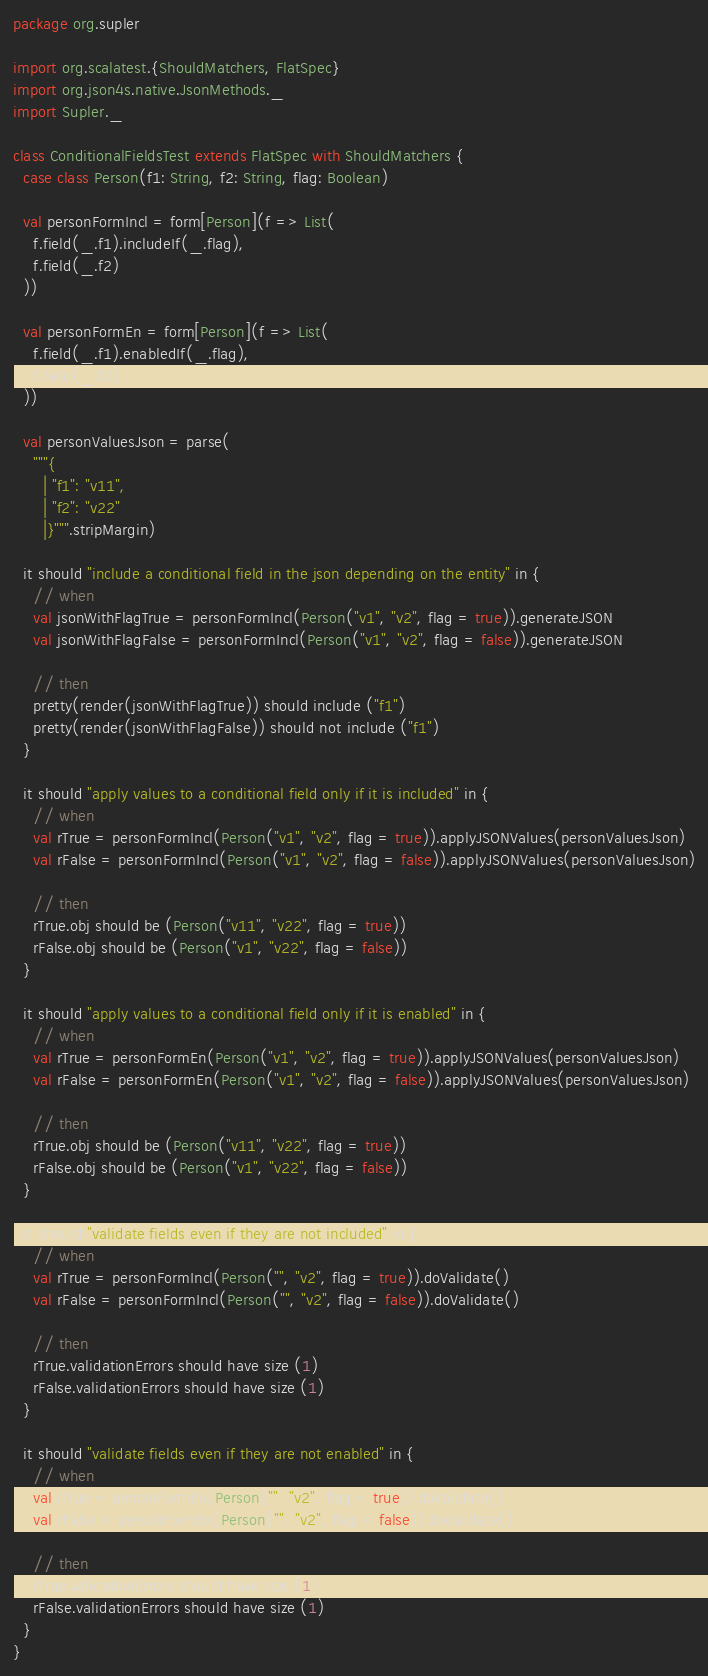<code> <loc_0><loc_0><loc_500><loc_500><_Scala_>package org.supler

import org.scalatest.{ShouldMatchers, FlatSpec}
import org.json4s.native.JsonMethods._
import Supler._

class ConditionalFieldsTest extends FlatSpec with ShouldMatchers {
  case class Person(f1: String, f2: String, flag: Boolean)

  val personFormIncl = form[Person](f => List(
    f.field(_.f1).includeIf(_.flag),
    f.field(_.f2)
  ))

  val personFormEn = form[Person](f => List(
    f.field(_.f1).enabledIf(_.flag),
    f.field(_.f2)
  ))

  val personValuesJson = parse(
    """{
      | "f1": "v11",
      | "f2": "v22"
      |}""".stripMargin)

  it should "include a conditional field in the json depending on the entity" in {
    // when
    val jsonWithFlagTrue = personFormIncl(Person("v1", "v2", flag = true)).generateJSON
    val jsonWithFlagFalse = personFormIncl(Person("v1", "v2", flag = false)).generateJSON

    // then
    pretty(render(jsonWithFlagTrue)) should include ("f1")
    pretty(render(jsonWithFlagFalse)) should not include ("f1")
  }

  it should "apply values to a conditional field only if it is included" in {
    // when
    val rTrue = personFormIncl(Person("v1", "v2", flag = true)).applyJSONValues(personValuesJson)
    val rFalse = personFormIncl(Person("v1", "v2", flag = false)).applyJSONValues(personValuesJson)

    // then
    rTrue.obj should be (Person("v11", "v22", flag = true))
    rFalse.obj should be (Person("v1", "v22", flag = false))
  }

  it should "apply values to a conditional field only if it is enabled" in {
    // when
    val rTrue = personFormEn(Person("v1", "v2", flag = true)).applyJSONValues(personValuesJson)
    val rFalse = personFormEn(Person("v1", "v2", flag = false)).applyJSONValues(personValuesJson)

    // then
    rTrue.obj should be (Person("v11", "v22", flag = true))
    rFalse.obj should be (Person("v1", "v22", flag = false))
  }

  it should "validate fields even if they are not included" in {
    // when
    val rTrue = personFormIncl(Person("", "v2", flag = true)).doValidate()
    val rFalse = personFormIncl(Person("", "v2", flag = false)).doValidate()

    // then
    rTrue.validationErrors should have size (1)
    rFalse.validationErrors should have size (1)
  }

  it should "validate fields even if they are not enabled" in {
    // when
    val rTrue = personFormEn(Person("", "v2", flag = true)).doValidate()
    val rFalse = personFormEn(Person("", "v2", flag = false)).doValidate()

    // then
    rTrue.validationErrors should have size (1)
    rFalse.validationErrors should have size (1)
  }
}
</code> 